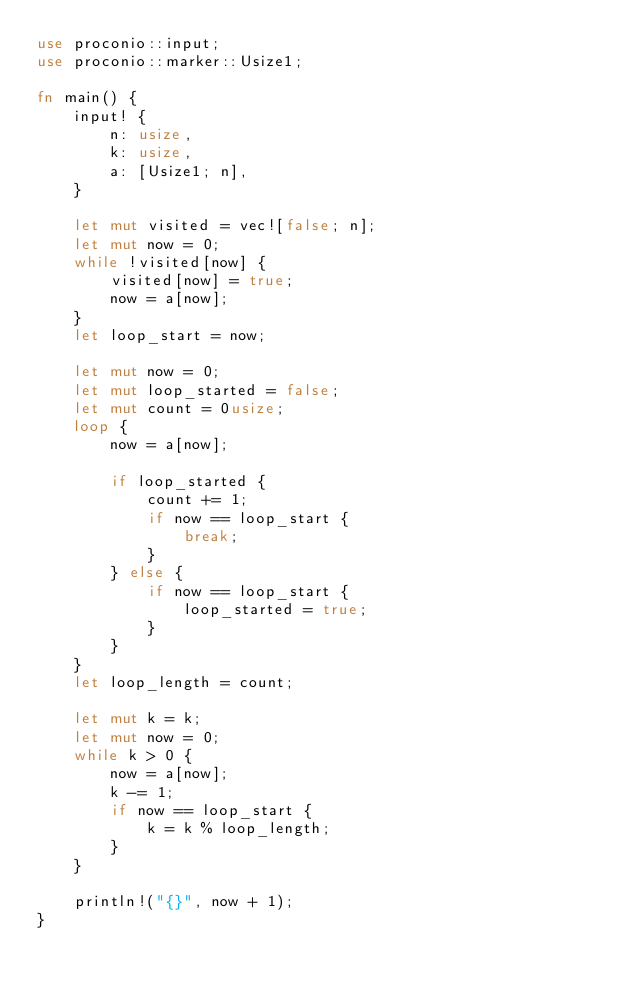<code> <loc_0><loc_0><loc_500><loc_500><_Rust_>use proconio::input;
use proconio::marker::Usize1;

fn main() {
    input! {
        n: usize,
        k: usize,
        a: [Usize1; n],
    }

    let mut visited = vec![false; n];
    let mut now = 0;
    while !visited[now] {
        visited[now] = true;
        now = a[now];
    }
    let loop_start = now;

    let mut now = 0;
    let mut loop_started = false;
    let mut count = 0usize;
    loop {
        now = a[now];

        if loop_started {
            count += 1;
            if now == loop_start {
                break;
            }
        } else {
            if now == loop_start {
                loop_started = true;
            }
        }
    }
    let loop_length = count;

    let mut k = k;
    let mut now = 0;
    while k > 0 {
        now = a[now];
        k -= 1;
        if now == loop_start {
            k = k % loop_length;
        }
    }

    println!("{}", now + 1);
}
</code> 